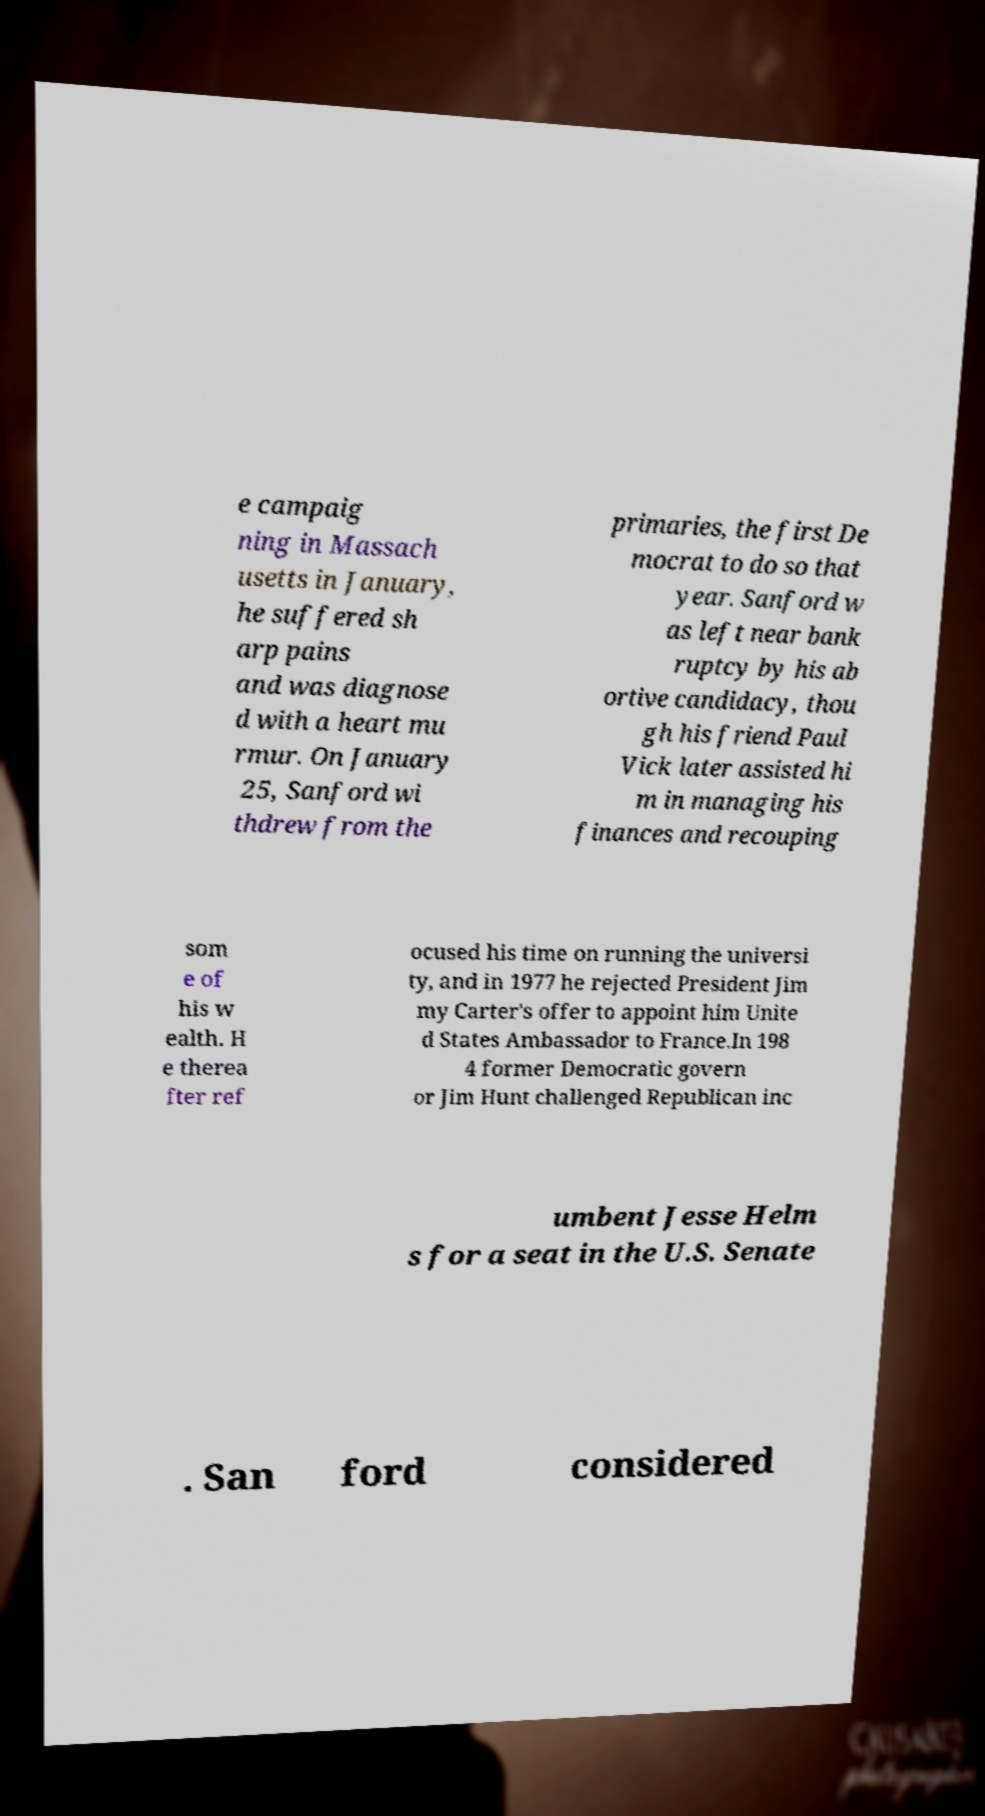I need the written content from this picture converted into text. Can you do that? e campaig ning in Massach usetts in January, he suffered sh arp pains and was diagnose d with a heart mu rmur. On January 25, Sanford wi thdrew from the primaries, the first De mocrat to do so that year. Sanford w as left near bank ruptcy by his ab ortive candidacy, thou gh his friend Paul Vick later assisted hi m in managing his finances and recouping som e of his w ealth. H e therea fter ref ocused his time on running the universi ty, and in 1977 he rejected President Jim my Carter's offer to appoint him Unite d States Ambassador to France.In 198 4 former Democratic govern or Jim Hunt challenged Republican inc umbent Jesse Helm s for a seat in the U.S. Senate . San ford considered 